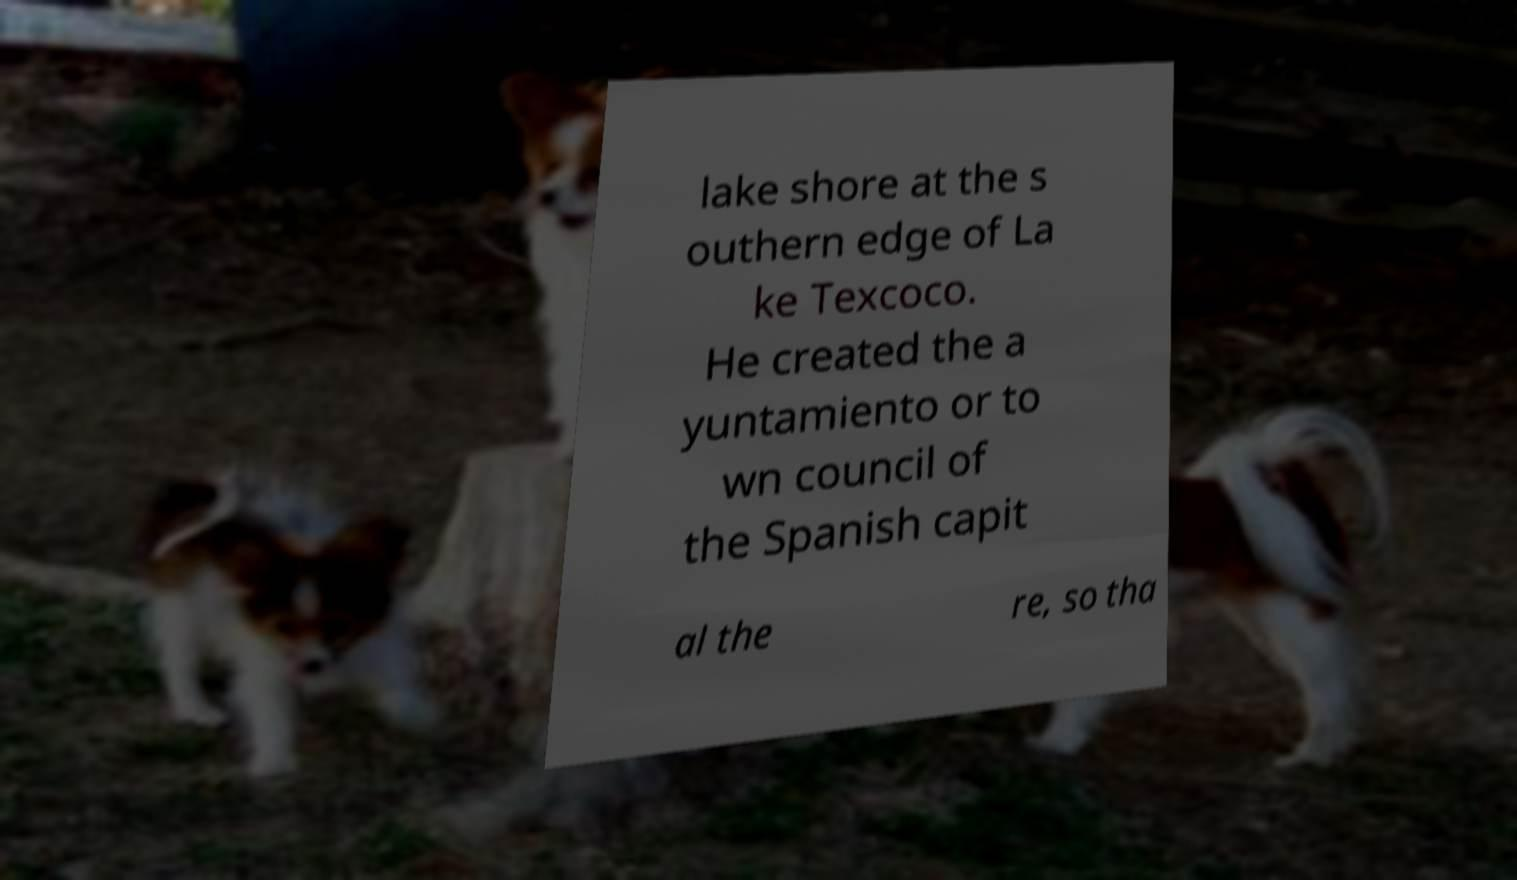Please identify and transcribe the text found in this image. lake shore at the s outhern edge of La ke Texcoco. He created the a yuntamiento or to wn council of the Spanish capit al the re, so tha 